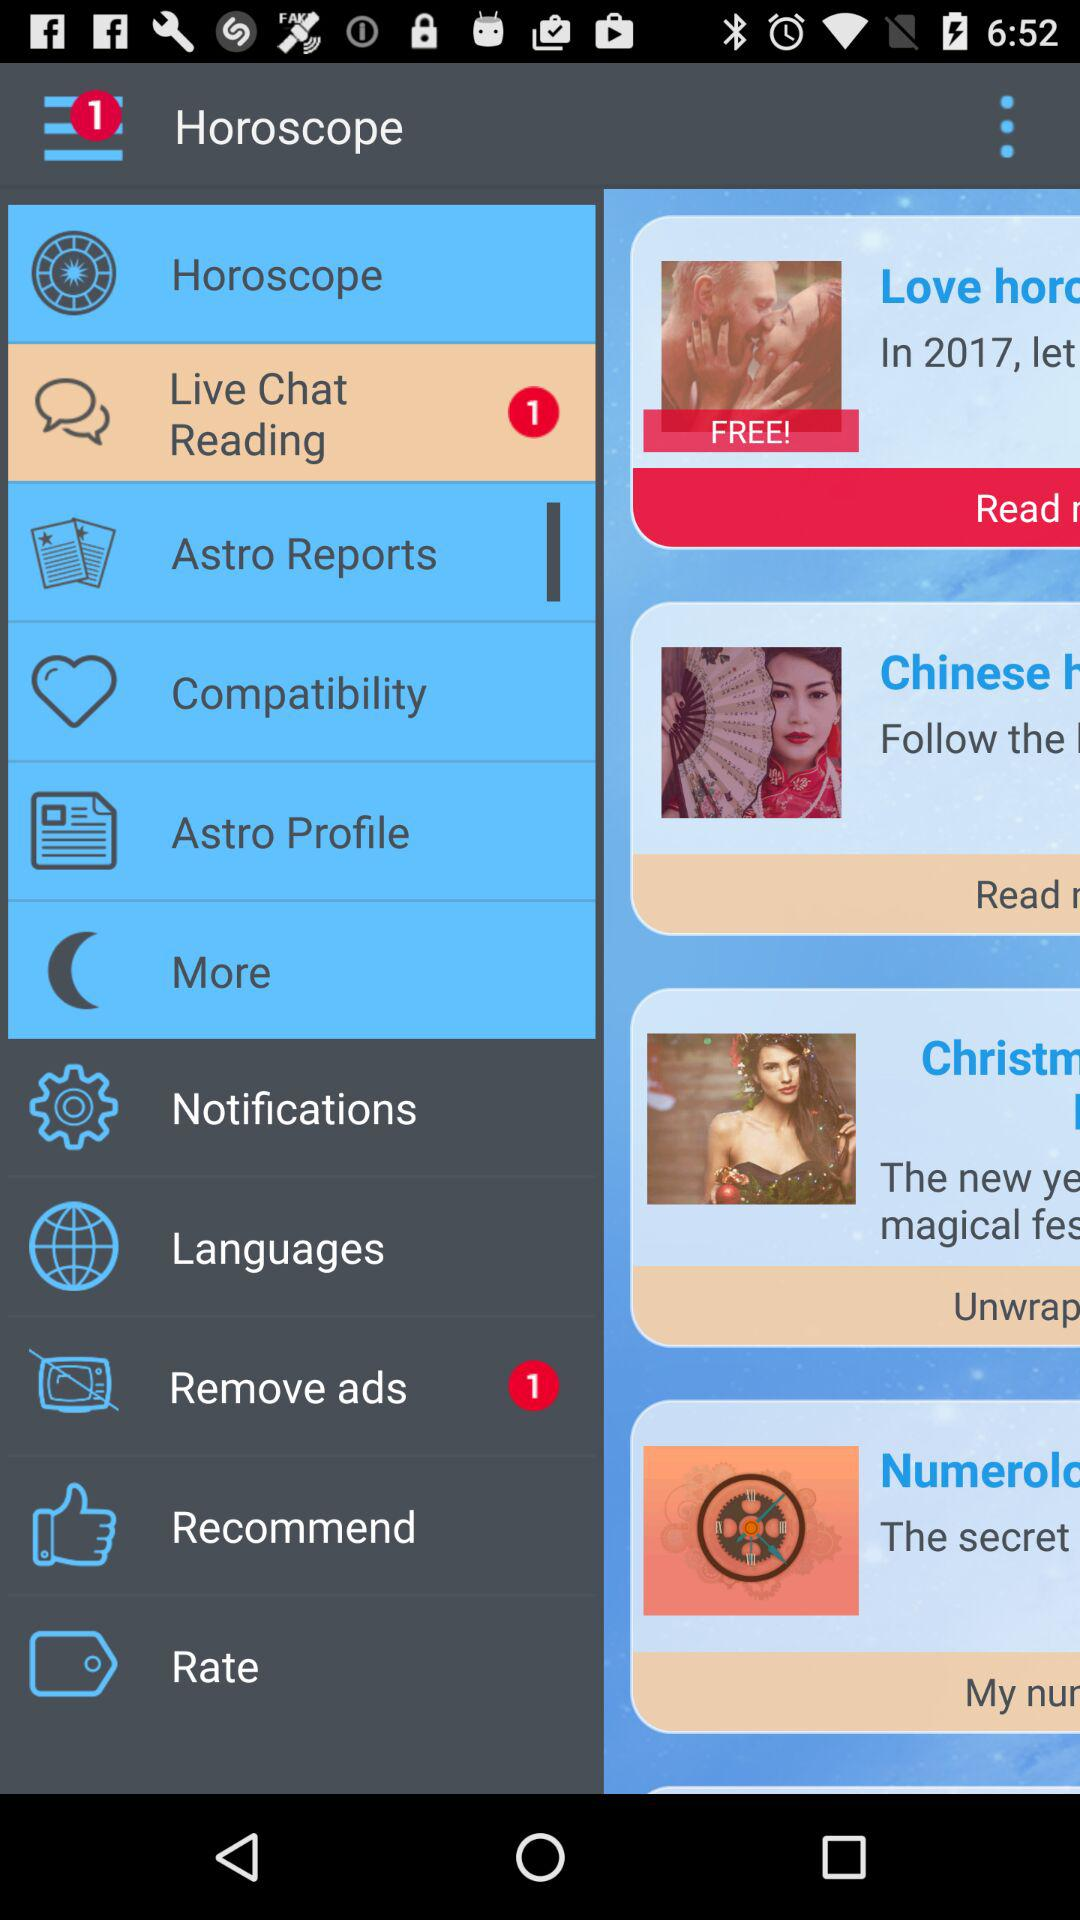How many notifications are unread in "Remove ads"? The unread notification is 1. 